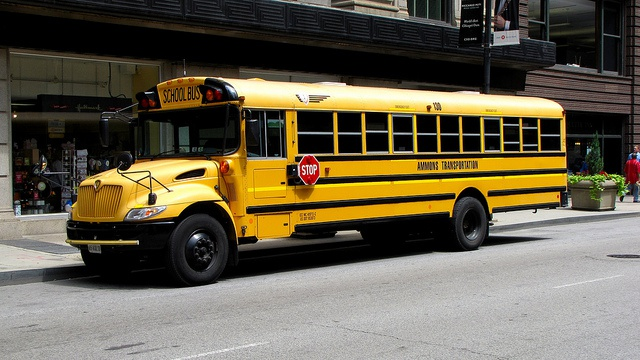Describe the objects in this image and their specific colors. I can see bus in black, orange, lightyellow, and olive tones, potted plant in black, darkgreen, and maroon tones, people in black, gray, maroon, and darkgray tones, people in black, maroon, brown, and gray tones, and stop sign in black, brown, lightgray, and lightpink tones in this image. 